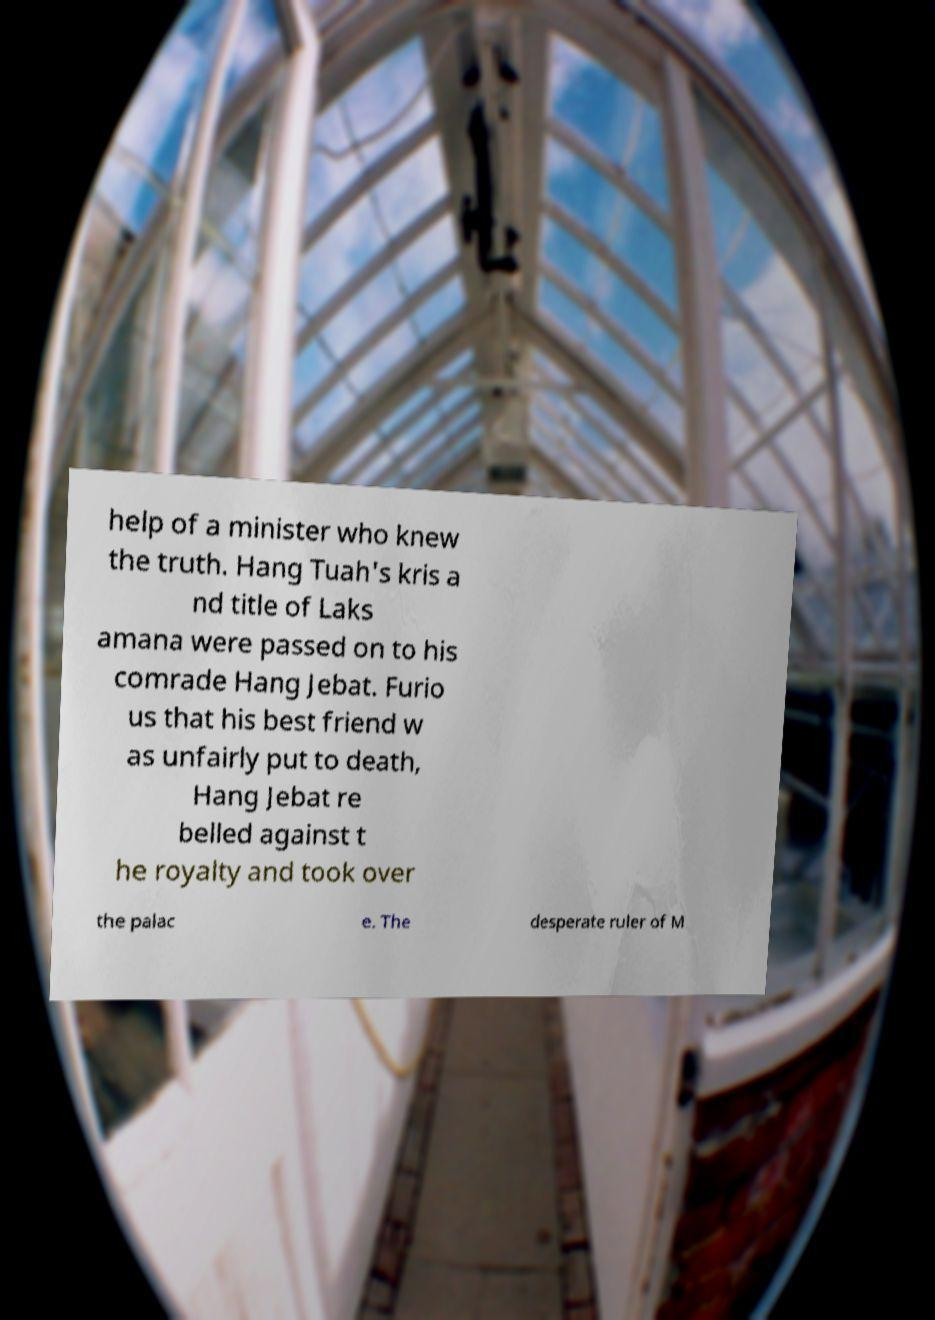There's text embedded in this image that I need extracted. Can you transcribe it verbatim? help of a minister who knew the truth. Hang Tuah's kris a nd title of Laks amana were passed on to his comrade Hang Jebat. Furio us that his best friend w as unfairly put to death, Hang Jebat re belled against t he royalty and took over the palac e. The desperate ruler of M 